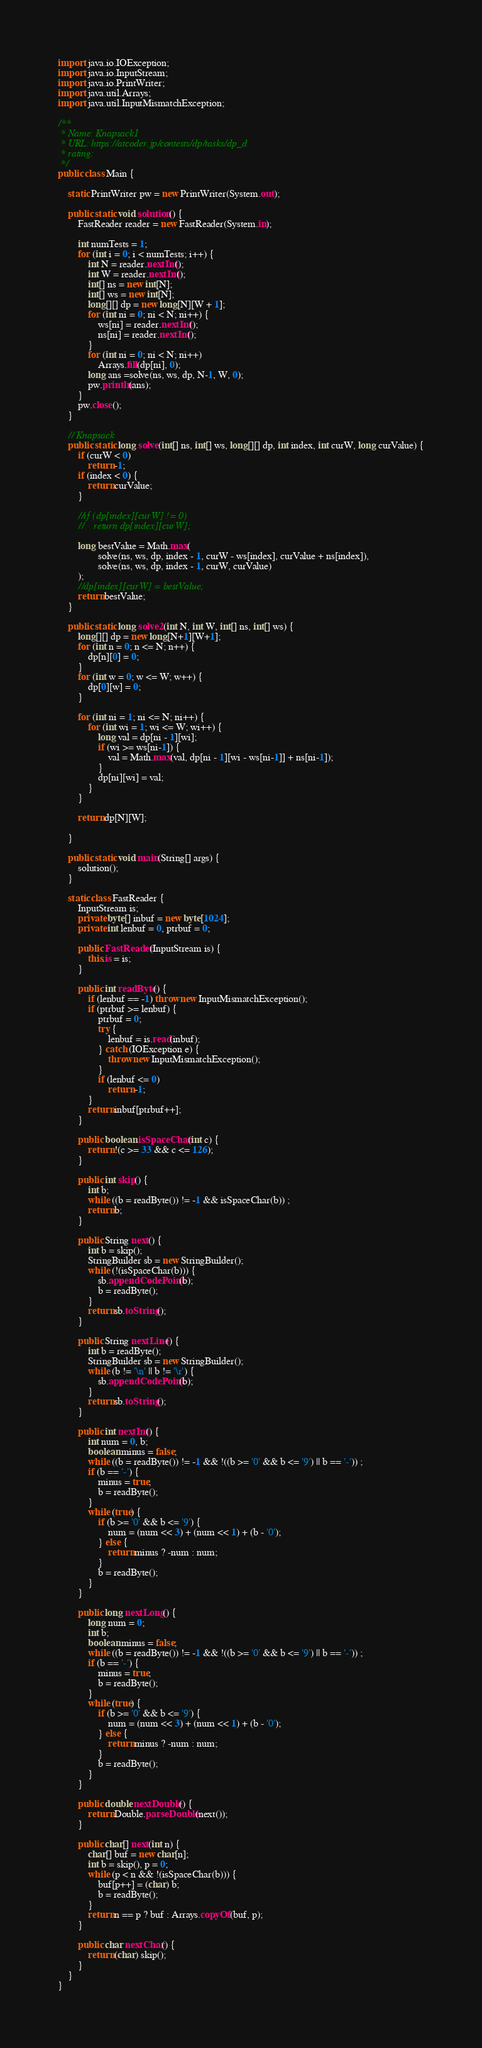<code> <loc_0><loc_0><loc_500><loc_500><_Java_>
import java.io.IOException;
import java.io.InputStream;
import java.io.PrintWriter;
import java.util.Arrays;
import java.util.InputMismatchException;

/**
 * Name: Knapsack1
 * URL: https://atcoder.jp/contests/dp/tasks/dp_d
 * rating:
 */
public class Main {

    static PrintWriter pw = new PrintWriter(System.out);

    public static void solution() {
        FastReader reader = new FastReader(System.in);

        int numTests = 1;
        for (int i = 0; i < numTests; i++) {
            int N = reader.nextInt();
            int W = reader.nextInt();
            int[] ns = new int[N];
            int[] ws = new int[N];
            long[][] dp = new long[N][W + 1];
            for (int ni = 0; ni < N; ni++) {
                ws[ni] = reader.nextInt();
                ns[ni] = reader.nextInt();
            }
            for (int ni = 0; ni < N; ni++)
                Arrays.fill(dp[ni], 0);
            long ans =solve(ns, ws, dp, N-1, W, 0);
            pw.println(ans);
        }
        pw.close();
    }

    // Knapsack
    public static long solve(int[] ns, int[] ws, long[][] dp, int index, int curW, long curValue) {
        if (curW < 0)
            return -1;
        if (index < 0) {
            return curValue;
        }

        //if (dp[index][curW] != 0)
        //    return dp[index][curW];

        long bestValue = Math.max(
                solve(ns, ws, dp, index - 1, curW - ws[index], curValue + ns[index]),
                solve(ns, ws, dp, index - 1, curW, curValue)
        );
        //dp[index][curW] = bestValue;
        return bestValue;
    }

    public static long solve2(int N, int W, int[] ns, int[] ws) {
        long[][] dp = new long[N+1][W+1];
        for (int n = 0; n <= N; n++) {
            dp[n][0] = 0;
        }
        for (int w = 0; w <= W; w++) {
            dp[0][w] = 0;
        }

        for (int ni = 1; ni <= N; ni++) {
            for (int wi = 1; wi <= W; wi++) {
                long val = dp[ni - 1][wi];
                if (wi >= ws[ni-1]) {
                    val = Math.max(val, dp[ni - 1][wi - ws[ni-1]] + ns[ni-1]);
                }
                dp[ni][wi] = val;
            }
        }

        return dp[N][W];

    }

    public static void main(String[] args) {
        solution();
    }

    static class FastReader {
        InputStream is;
        private byte[] inbuf = new byte[1024];
        private int lenbuf = 0, ptrbuf = 0;

        public FastReader(InputStream is) {
            this.is = is;
        }

        public int readByte() {
            if (lenbuf == -1) throw new InputMismatchException();
            if (ptrbuf >= lenbuf) {
                ptrbuf = 0;
                try {
                    lenbuf = is.read(inbuf);
                } catch (IOException e) {
                    throw new InputMismatchException();
                }
                if (lenbuf <= 0)
                    return -1;
            }
            return inbuf[ptrbuf++];
        }

        public boolean isSpaceChar(int c) {
            return !(c >= 33 && c <= 126);
        }

        public int skip() {
            int b;
            while ((b = readByte()) != -1 && isSpaceChar(b)) ;
            return b;
        }

        public String next() {
            int b = skip();
            StringBuilder sb = new StringBuilder();
            while (!(isSpaceChar(b))) {
                sb.appendCodePoint(b);
                b = readByte();
            }
            return sb.toString();
        }

        public String nextLine() {
            int b = readByte();
            StringBuilder sb = new StringBuilder();
            while (b != '\n' || b != '\r') {
                sb.appendCodePoint(b);
            }
            return sb.toString();
        }

        public int nextInt() {
            int num = 0, b;
            boolean minus = false;
            while ((b = readByte()) != -1 && !((b >= '0' && b <= '9') || b == '-')) ;
            if (b == '-') {
                minus = true;
                b = readByte();
            }
            while (true) {
                if (b >= '0' && b <= '9') {
                    num = (num << 3) + (num << 1) + (b - '0');
                } else {
                    return minus ? -num : num;
                }
                b = readByte();
            }
        }

        public long nextLong() {
            long num = 0;
            int b;
            boolean minus = false;
            while ((b = readByte()) != -1 && !((b >= '0' && b <= '9') || b == '-')) ;
            if (b == '-') {
                minus = true;
                b = readByte();
            }
            while (true) {
                if (b >= '0' && b <= '9') {
                    num = (num << 3) + (num << 1) + (b - '0');
                } else {
                    return minus ? -num : num;
                }
                b = readByte();
            }
        }

        public double nextDouble() {
            return Double.parseDouble(next());
        }

        public char[] next(int n) {
            char[] buf = new char[n];
            int b = skip(), p = 0;
            while (p < n && !(isSpaceChar(b))) {
                buf[p++] = (char) b;
                b = readByte();
            }
            return n == p ? buf : Arrays.copyOf(buf, p);
        }

        public char nextChar() {
            return (char) skip();
        }
    }
}
</code> 